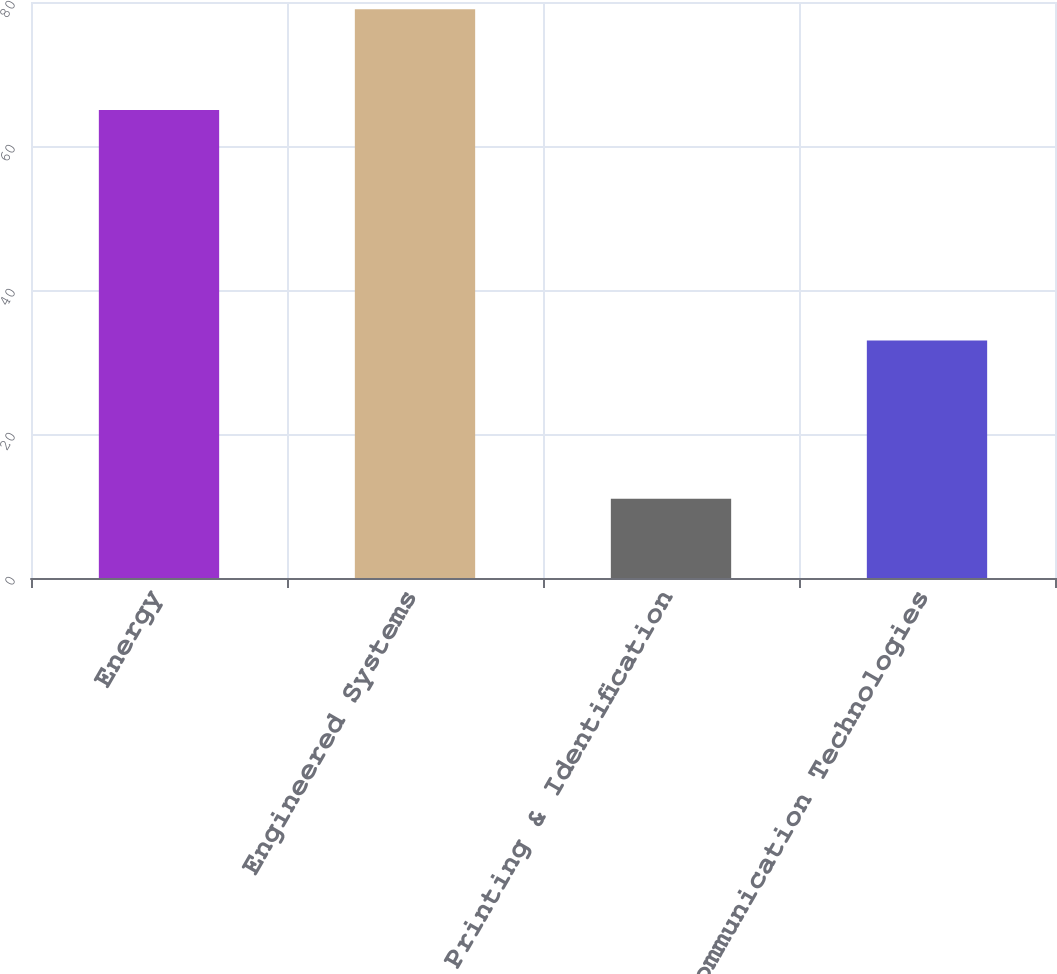<chart> <loc_0><loc_0><loc_500><loc_500><bar_chart><fcel>Energy<fcel>Engineered Systems<fcel>Printing & Identification<fcel>Communication Technologies<nl><fcel>65<fcel>79<fcel>11<fcel>33<nl></chart> 